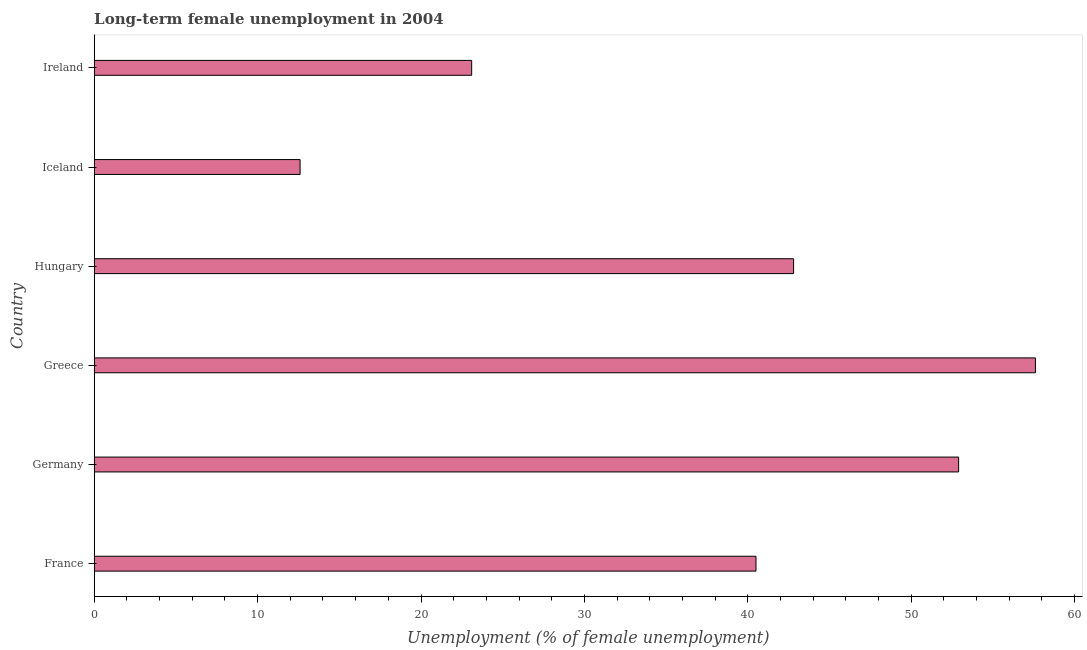Does the graph contain any zero values?
Ensure brevity in your answer.  No. Does the graph contain grids?
Your answer should be very brief. No. What is the title of the graph?
Provide a succinct answer. Long-term female unemployment in 2004. What is the label or title of the X-axis?
Ensure brevity in your answer.  Unemployment (% of female unemployment). What is the label or title of the Y-axis?
Your response must be concise. Country. What is the long-term female unemployment in France?
Offer a terse response. 40.5. Across all countries, what is the maximum long-term female unemployment?
Your response must be concise. 57.6. Across all countries, what is the minimum long-term female unemployment?
Provide a short and direct response. 12.6. In which country was the long-term female unemployment minimum?
Offer a terse response. Iceland. What is the sum of the long-term female unemployment?
Keep it short and to the point. 229.5. What is the difference between the long-term female unemployment in France and Greece?
Your response must be concise. -17.1. What is the average long-term female unemployment per country?
Provide a succinct answer. 38.25. What is the median long-term female unemployment?
Ensure brevity in your answer.  41.65. In how many countries, is the long-term female unemployment greater than 4 %?
Offer a very short reply. 6. What is the ratio of the long-term female unemployment in Greece to that in Hungary?
Your answer should be compact. 1.35. What is the difference between the highest and the lowest long-term female unemployment?
Your response must be concise. 45. How many bars are there?
Provide a short and direct response. 6. Are all the bars in the graph horizontal?
Provide a succinct answer. Yes. What is the Unemployment (% of female unemployment) in France?
Offer a very short reply. 40.5. What is the Unemployment (% of female unemployment) in Germany?
Give a very brief answer. 52.9. What is the Unemployment (% of female unemployment) in Greece?
Your response must be concise. 57.6. What is the Unemployment (% of female unemployment) in Hungary?
Ensure brevity in your answer.  42.8. What is the Unemployment (% of female unemployment) of Iceland?
Provide a succinct answer. 12.6. What is the Unemployment (% of female unemployment) in Ireland?
Provide a short and direct response. 23.1. What is the difference between the Unemployment (% of female unemployment) in France and Germany?
Ensure brevity in your answer.  -12.4. What is the difference between the Unemployment (% of female unemployment) in France and Greece?
Your answer should be very brief. -17.1. What is the difference between the Unemployment (% of female unemployment) in France and Hungary?
Offer a terse response. -2.3. What is the difference between the Unemployment (% of female unemployment) in France and Iceland?
Provide a short and direct response. 27.9. What is the difference between the Unemployment (% of female unemployment) in France and Ireland?
Ensure brevity in your answer.  17.4. What is the difference between the Unemployment (% of female unemployment) in Germany and Hungary?
Provide a short and direct response. 10.1. What is the difference between the Unemployment (% of female unemployment) in Germany and Iceland?
Give a very brief answer. 40.3. What is the difference between the Unemployment (% of female unemployment) in Germany and Ireland?
Provide a succinct answer. 29.8. What is the difference between the Unemployment (% of female unemployment) in Greece and Iceland?
Give a very brief answer. 45. What is the difference between the Unemployment (% of female unemployment) in Greece and Ireland?
Provide a succinct answer. 34.5. What is the difference between the Unemployment (% of female unemployment) in Hungary and Iceland?
Your answer should be very brief. 30.2. What is the ratio of the Unemployment (% of female unemployment) in France to that in Germany?
Offer a terse response. 0.77. What is the ratio of the Unemployment (% of female unemployment) in France to that in Greece?
Keep it short and to the point. 0.7. What is the ratio of the Unemployment (% of female unemployment) in France to that in Hungary?
Your response must be concise. 0.95. What is the ratio of the Unemployment (% of female unemployment) in France to that in Iceland?
Give a very brief answer. 3.21. What is the ratio of the Unemployment (% of female unemployment) in France to that in Ireland?
Provide a succinct answer. 1.75. What is the ratio of the Unemployment (% of female unemployment) in Germany to that in Greece?
Your answer should be compact. 0.92. What is the ratio of the Unemployment (% of female unemployment) in Germany to that in Hungary?
Offer a terse response. 1.24. What is the ratio of the Unemployment (% of female unemployment) in Germany to that in Iceland?
Offer a very short reply. 4.2. What is the ratio of the Unemployment (% of female unemployment) in Germany to that in Ireland?
Your answer should be very brief. 2.29. What is the ratio of the Unemployment (% of female unemployment) in Greece to that in Hungary?
Your response must be concise. 1.35. What is the ratio of the Unemployment (% of female unemployment) in Greece to that in Iceland?
Ensure brevity in your answer.  4.57. What is the ratio of the Unemployment (% of female unemployment) in Greece to that in Ireland?
Give a very brief answer. 2.49. What is the ratio of the Unemployment (% of female unemployment) in Hungary to that in Iceland?
Provide a succinct answer. 3.4. What is the ratio of the Unemployment (% of female unemployment) in Hungary to that in Ireland?
Make the answer very short. 1.85. What is the ratio of the Unemployment (% of female unemployment) in Iceland to that in Ireland?
Make the answer very short. 0.55. 